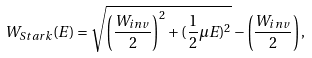<formula> <loc_0><loc_0><loc_500><loc_500>W _ { S t a r k } ( E ) = \sqrt { \left ( \frac { W _ { i n v } } { 2 } \right ) ^ { 2 } + ( \frac { 1 } { 2 } \mu E ) ^ { 2 } } - \left ( \frac { W _ { i n v } } { 2 } \right ) ,</formula> 